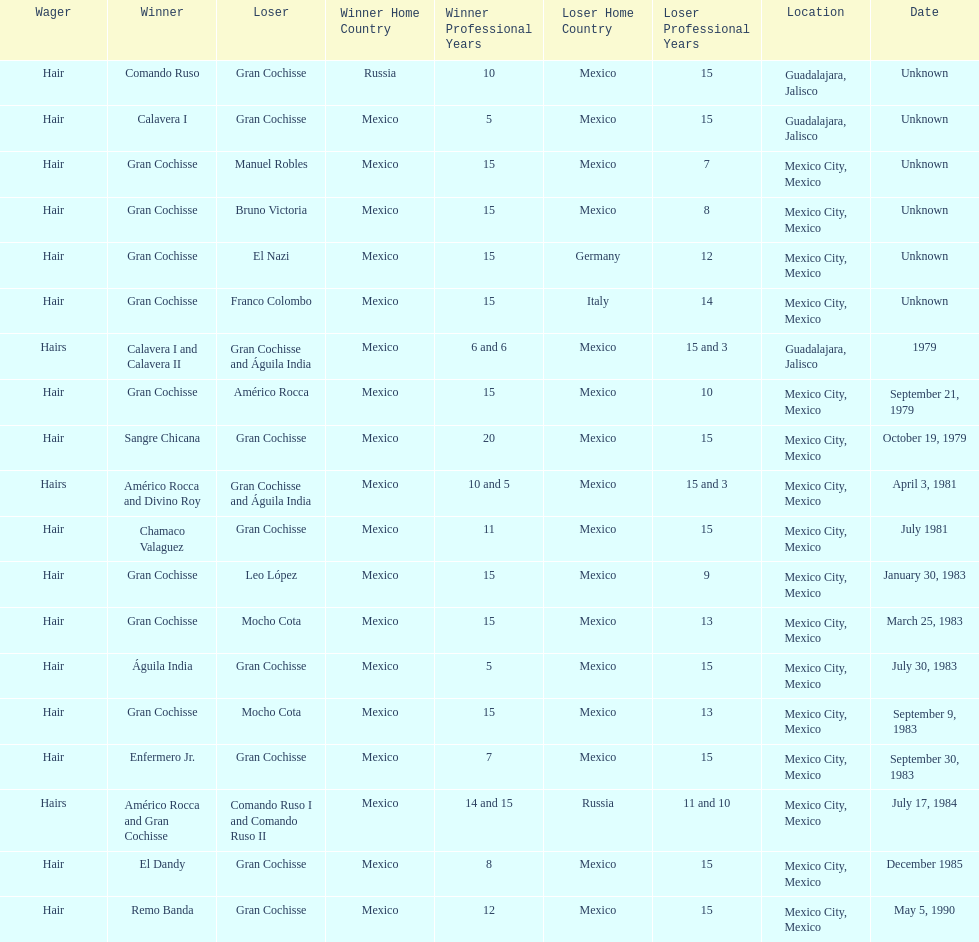When did bruno victoria lose his first game? Unknown. Could you help me parse every detail presented in this table? {'header': ['Wager', 'Winner', 'Loser', 'Winner Home Country', 'Winner Professional Years', 'Loser Home Country', 'Loser Professional Years', 'Location', 'Date'], 'rows': [['Hair', 'Comando Ruso', 'Gran Cochisse', 'Russia', '10', 'Mexico', '15', 'Guadalajara, Jalisco', 'Unknown'], ['Hair', 'Calavera I', 'Gran Cochisse', 'Mexico', '5', 'Mexico', '15', 'Guadalajara, Jalisco', 'Unknown'], ['Hair', 'Gran Cochisse', 'Manuel Robles', 'Mexico', '15', 'Mexico', '7', 'Mexico City, Mexico', 'Unknown'], ['Hair', 'Gran Cochisse', 'Bruno Victoria', 'Mexico', '15', 'Mexico', '8', 'Mexico City, Mexico', 'Unknown'], ['Hair', 'Gran Cochisse', 'El Nazi', 'Mexico', '15', 'Germany', '12', 'Mexico City, Mexico', 'Unknown'], ['Hair', 'Gran Cochisse', 'Franco Colombo', 'Mexico', '15', 'Italy', '14', 'Mexico City, Mexico', 'Unknown'], ['Hairs', 'Calavera I and Calavera II', 'Gran Cochisse and Águila India', 'Mexico', '6 and 6', 'Mexico', '15 and 3', 'Guadalajara, Jalisco', '1979'], ['Hair', 'Gran Cochisse', 'Américo Rocca', 'Mexico', '15', 'Mexico', '10', 'Mexico City, Mexico', 'September 21, 1979'], ['Hair', 'Sangre Chicana', 'Gran Cochisse', 'Mexico', '20', 'Mexico', '15', 'Mexico City, Mexico', 'October 19, 1979'], ['Hairs', 'Américo Rocca and Divino Roy', 'Gran Cochisse and Águila India', 'Mexico', '10 and 5', 'Mexico', '15 and 3', 'Mexico City, Mexico', 'April 3, 1981'], ['Hair', 'Chamaco Valaguez', 'Gran Cochisse', 'Mexico', '11', 'Mexico', '15', 'Mexico City, Mexico', 'July 1981'], ['Hair', 'Gran Cochisse', 'Leo López', 'Mexico', '15', 'Mexico', '9', 'Mexico City, Mexico', 'January 30, 1983'], ['Hair', 'Gran Cochisse', 'Mocho Cota', 'Mexico', '15', 'Mexico', '13', 'Mexico City, Mexico', 'March 25, 1983'], ['Hair', 'Águila India', 'Gran Cochisse', 'Mexico', '5', 'Mexico', '15', 'Mexico City, Mexico', 'July 30, 1983'], ['Hair', 'Gran Cochisse', 'Mocho Cota', 'Mexico', '15', 'Mexico', '13', 'Mexico City, Mexico', 'September 9, 1983'], ['Hair', 'Enfermero Jr.', 'Gran Cochisse', 'Mexico', '7', 'Mexico', '15', 'Mexico City, Mexico', 'September 30, 1983'], ['Hairs', 'Américo Rocca and Gran Cochisse', 'Comando Ruso I and Comando Ruso II', 'Mexico', '14 and 15', 'Russia', '11 and 10', 'Mexico City, Mexico', 'July 17, 1984'], ['Hair', 'El Dandy', 'Gran Cochisse', 'Mexico', '8', 'Mexico', '15', 'Mexico City, Mexico', 'December 1985'], ['Hair', 'Remo Banda', 'Gran Cochisse', 'Mexico', '12', 'Mexico', '15', 'Mexico City, Mexico', 'May 5, 1990']]} 